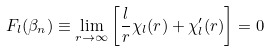Convert formula to latex. <formula><loc_0><loc_0><loc_500><loc_500>F _ { l } ( \beta _ { n } ) \equiv \lim _ { r \rightarrow \infty } \left [ \frac { l } { r } \chi _ { l } ( r ) + \chi ^ { \prime } _ { l } ( r ) \right ] = 0</formula> 